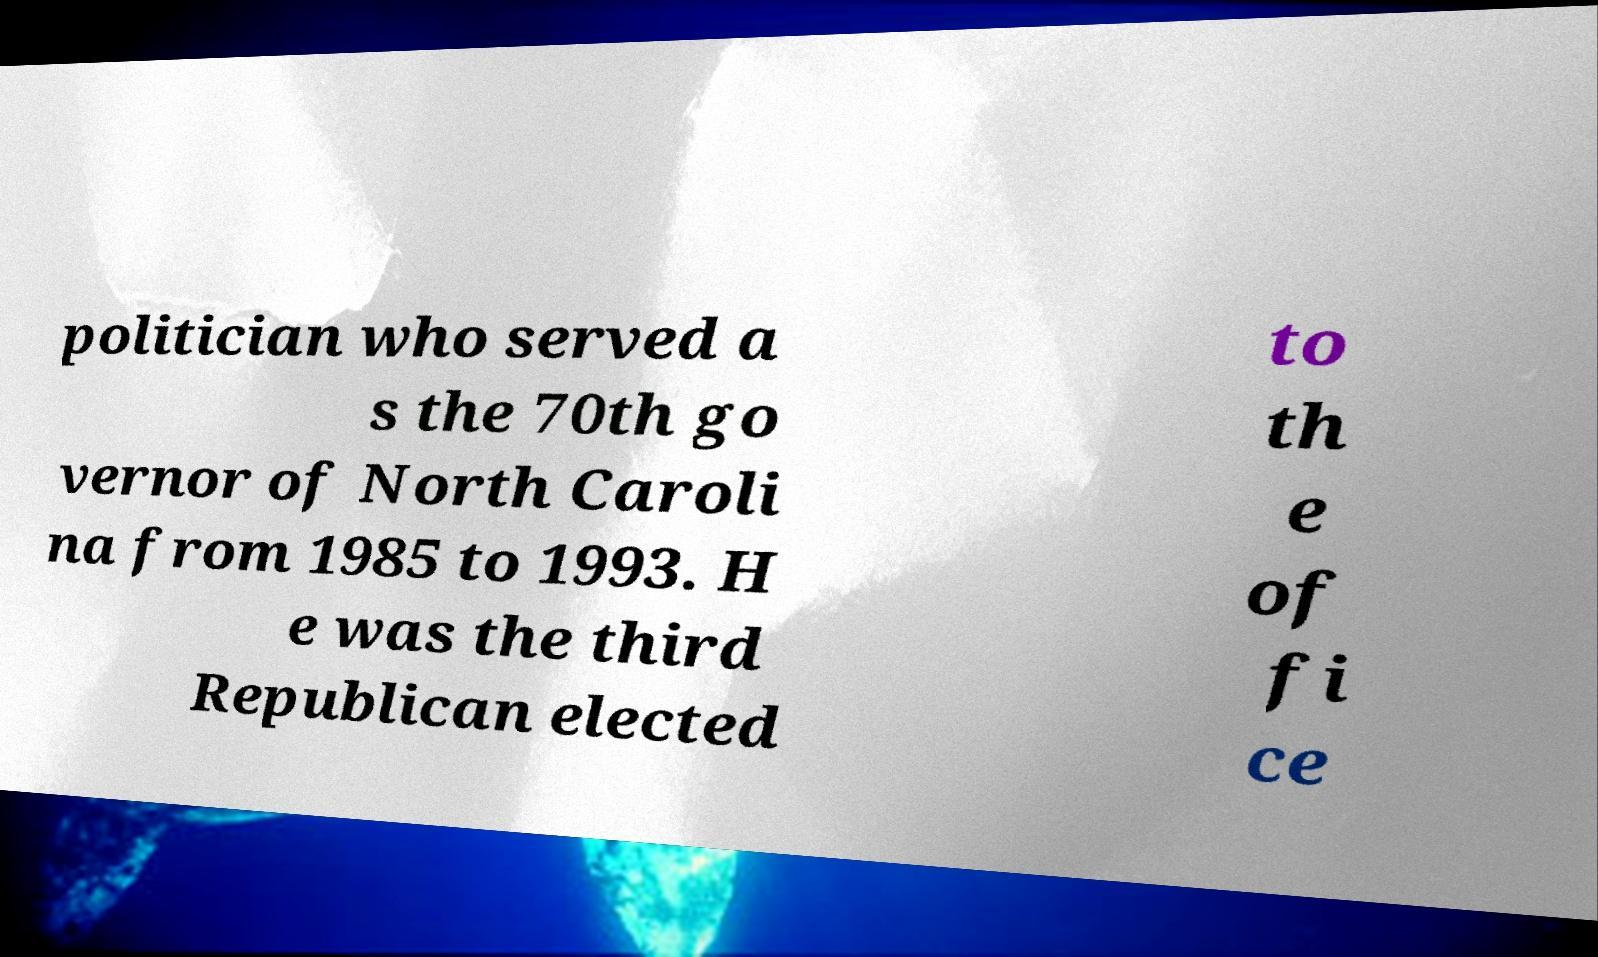Could you extract and type out the text from this image? politician who served a s the 70th go vernor of North Caroli na from 1985 to 1993. H e was the third Republican elected to th e of fi ce 